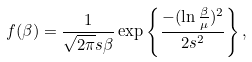Convert formula to latex. <formula><loc_0><loc_0><loc_500><loc_500>f ( \beta ) = \frac { 1 } { \sqrt { 2 \pi } s \beta } \exp \left \{ \frac { - ( \ln \frac { \beta } { \mu } ) ^ { 2 } } { 2 s ^ { 2 } } \right \} ,</formula> 